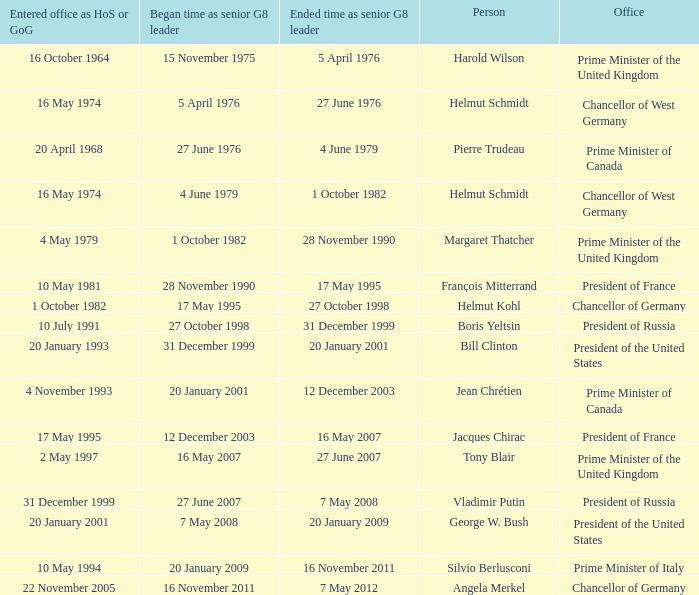When did the Prime Minister of Italy take office? 10 May 1994. 